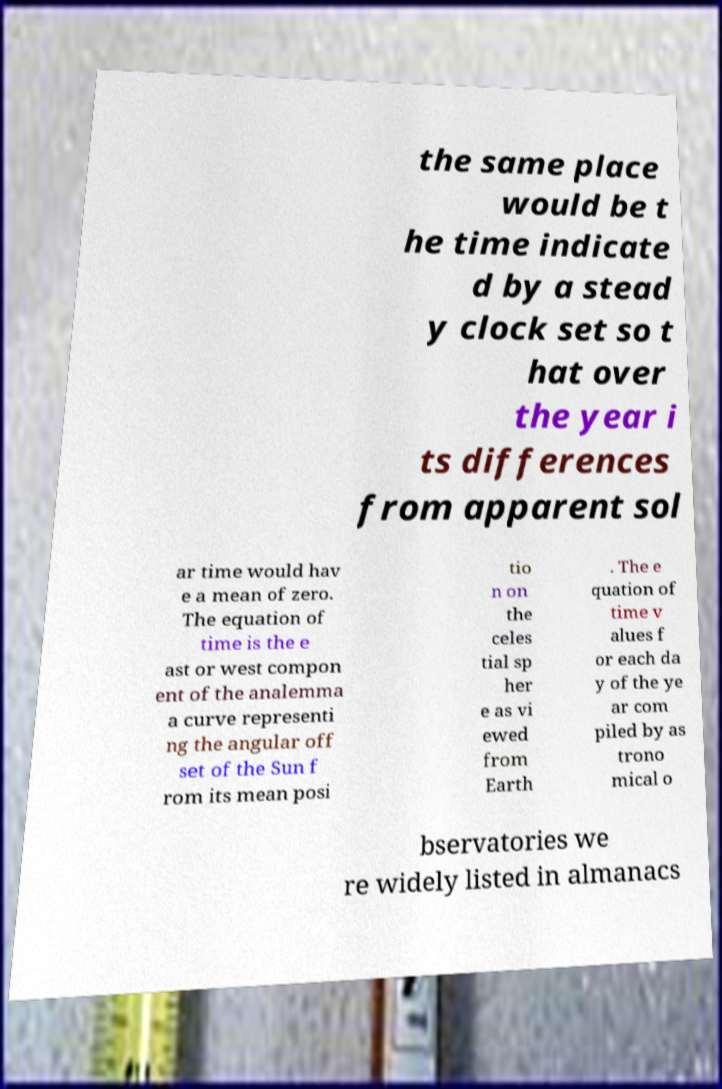Could you assist in decoding the text presented in this image and type it out clearly? the same place would be t he time indicate d by a stead y clock set so t hat over the year i ts differences from apparent sol ar time would hav e a mean of zero. The equation of time is the e ast or west compon ent of the analemma a curve representi ng the angular off set of the Sun f rom its mean posi tio n on the celes tial sp her e as vi ewed from Earth . The e quation of time v alues f or each da y of the ye ar com piled by as trono mical o bservatories we re widely listed in almanacs 